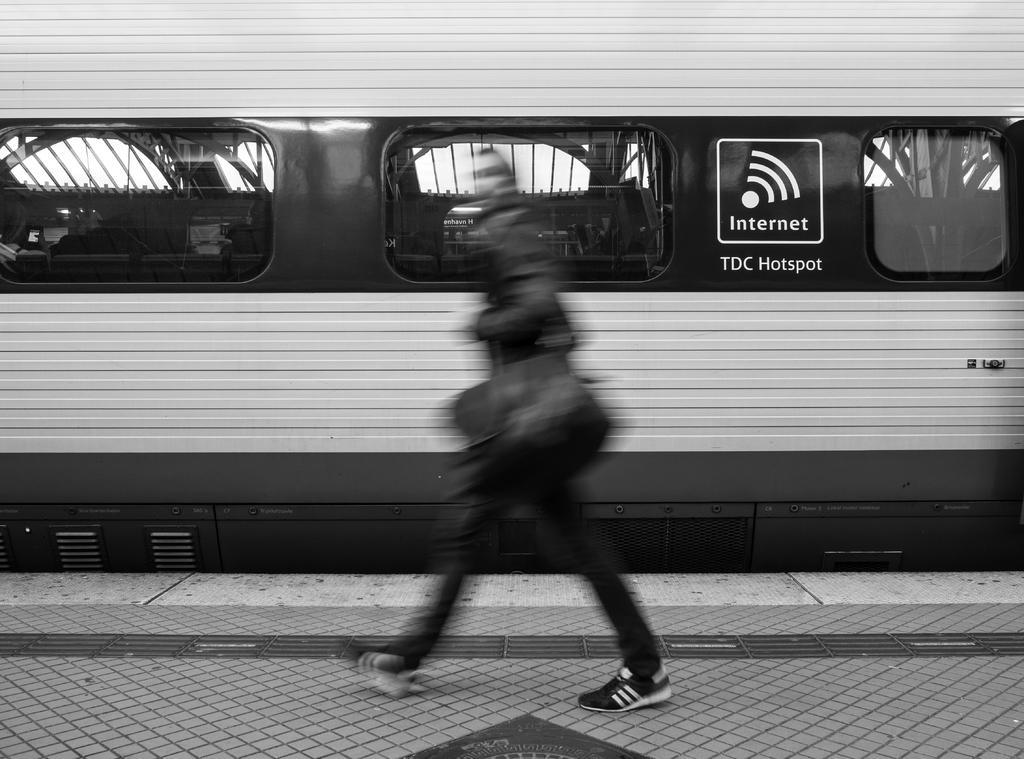In one or two sentences, can you explain what this image depicts? This image is a black and white image. This image is taken outdoors. At the bottom of the image there is a platform. In the middle of the image a person is walking on the platform. In the background there is a train. 